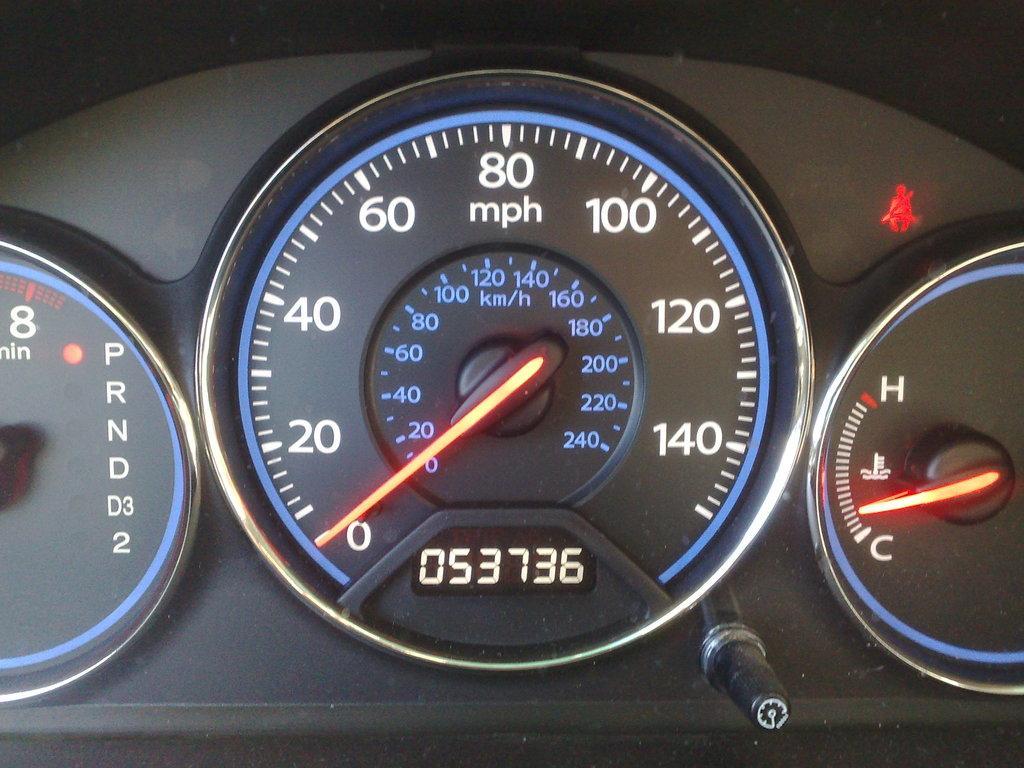Can you describe this image briefly? In this picture we can see speedometer, fuel meter and tachometer of a vehicle, we can also see a button at the bottom. 